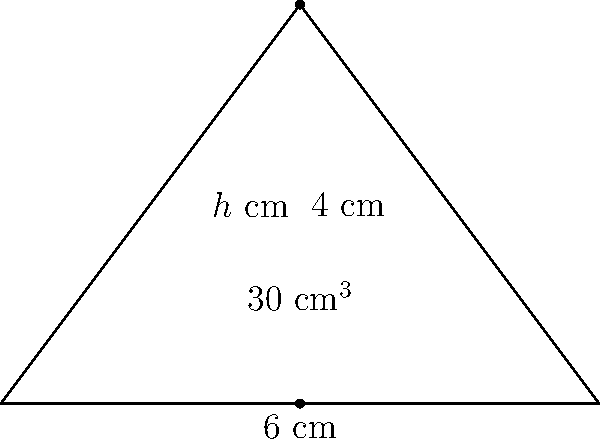You've designed a unique triangular fish tank for a new species of freshwater fish you hope to discover. The tank has a base length of 6 cm and a height of 4 cm. If the volume of the tank is 30 cm³, what is the length of the tank (h) in cm? Let's approach this step-by-step:

1) The volume of a triangular prism is given by the formula:
   $$V = \frac{1}{2} \times b \times h \times l$$
   Where V is volume, b is base length, h is height, and l is length.

2) We know:
   V = 30 cm³
   b = 6 cm
   h = 4 cm
   We need to find l.

3) Let's substitute these values into our formula:
   $$30 = \frac{1}{2} \times 6 \times 4 \times l$$

4) Simplify the right side:
   $$30 = 12l$$

5) Now, solve for l:
   $$l = \frac{30}{12} = 2.5$$

Therefore, the length of the tank is 2.5 cm.
Answer: 2.5 cm 